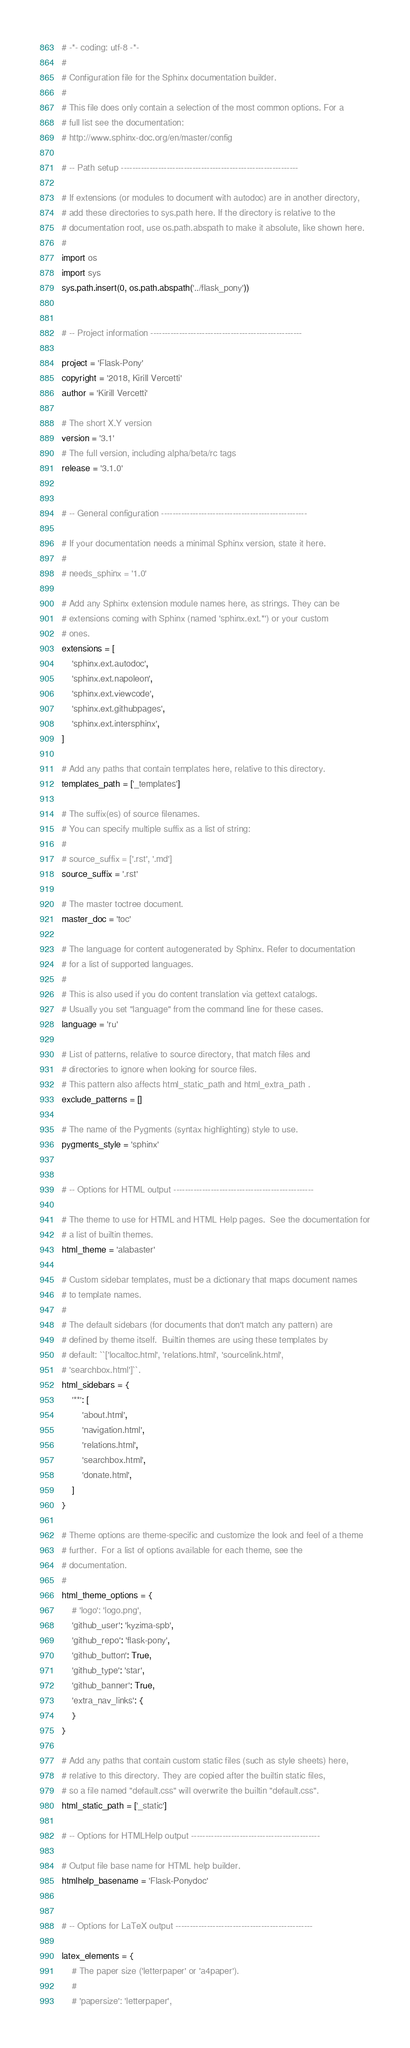<code> <loc_0><loc_0><loc_500><loc_500><_Python_># -*- coding: utf-8 -*-
#
# Configuration file for the Sphinx documentation builder.
#
# This file does only contain a selection of the most common options. For a
# full list see the documentation:
# http://www.sphinx-doc.org/en/master/config

# -- Path setup --------------------------------------------------------------

# If extensions (or modules to document with autodoc) are in another directory,
# add these directories to sys.path here. If the directory is relative to the
# documentation root, use os.path.abspath to make it absolute, like shown here.
#
import os
import sys
sys.path.insert(0, os.path.abspath('../flask_pony'))


# -- Project information -----------------------------------------------------

project = 'Flask-Pony'
copyright = '2018, Kirill Vercetti'
author = 'Kirill Vercetti'

# The short X.Y version
version = '3.1'
# The full version, including alpha/beta/rc tags
release = '3.1.0'


# -- General configuration ---------------------------------------------------

# If your documentation needs a minimal Sphinx version, state it here.
#
# needs_sphinx = '1.0'

# Add any Sphinx extension module names here, as strings. They can be
# extensions coming with Sphinx (named 'sphinx.ext.*') or your custom
# ones.
extensions = [
    'sphinx.ext.autodoc',
    'sphinx.ext.napoleon',
    'sphinx.ext.viewcode',
    'sphinx.ext.githubpages',
    'sphinx.ext.intersphinx',
]

# Add any paths that contain templates here, relative to this directory.
templates_path = ['_templates']

# The suffix(es) of source filenames.
# You can specify multiple suffix as a list of string:
#
# source_suffix = ['.rst', '.md']
source_suffix = '.rst'

# The master toctree document.
master_doc = 'toc'

# The language for content autogenerated by Sphinx. Refer to documentation
# for a list of supported languages.
#
# This is also used if you do content translation via gettext catalogs.
# Usually you set "language" from the command line for these cases.
language = 'ru'

# List of patterns, relative to source directory, that match files and
# directories to ignore when looking for source files.
# This pattern also affects html_static_path and html_extra_path .
exclude_patterns = []

# The name of the Pygments (syntax highlighting) style to use.
pygments_style = 'sphinx'


# -- Options for HTML output -------------------------------------------------

# The theme to use for HTML and HTML Help pages.  See the documentation for
# a list of builtin themes.
html_theme = 'alabaster'

# Custom sidebar templates, must be a dictionary that maps document names
# to template names.
#
# The default sidebars (for documents that don't match any pattern) are
# defined by theme itself.  Builtin themes are using these templates by
# default: ``['localtoc.html', 'relations.html', 'sourcelink.html',
# 'searchbox.html']``.
html_sidebars = {
    '**': [
        'about.html',
        'navigation.html',
        'relations.html',
        'searchbox.html',
        'donate.html',
    ]
}

# Theme options are theme-specific and customize the look and feel of a theme
# further.  For a list of options available for each theme, see the
# documentation.
#
html_theme_options = {
    # 'logo': 'logo.png',
    'github_user': 'kyzima-spb',
    'github_repo': 'flask-pony',
    'github_button': True,
    'github_type': 'star',
    'github_banner': True,
    'extra_nav_links': {
    }
}

# Add any paths that contain custom static files (such as style sheets) here,
# relative to this directory. They are copied after the builtin static files,
# so a file named "default.css" will overwrite the builtin "default.css".
html_static_path = ['_static']

# -- Options for HTMLHelp output ---------------------------------------------

# Output file base name for HTML help builder.
htmlhelp_basename = 'Flask-Ponydoc'


# -- Options for LaTeX output ------------------------------------------------

latex_elements = {
    # The paper size ('letterpaper' or 'a4paper').
    #
    # 'papersize': 'letterpaper',
</code> 